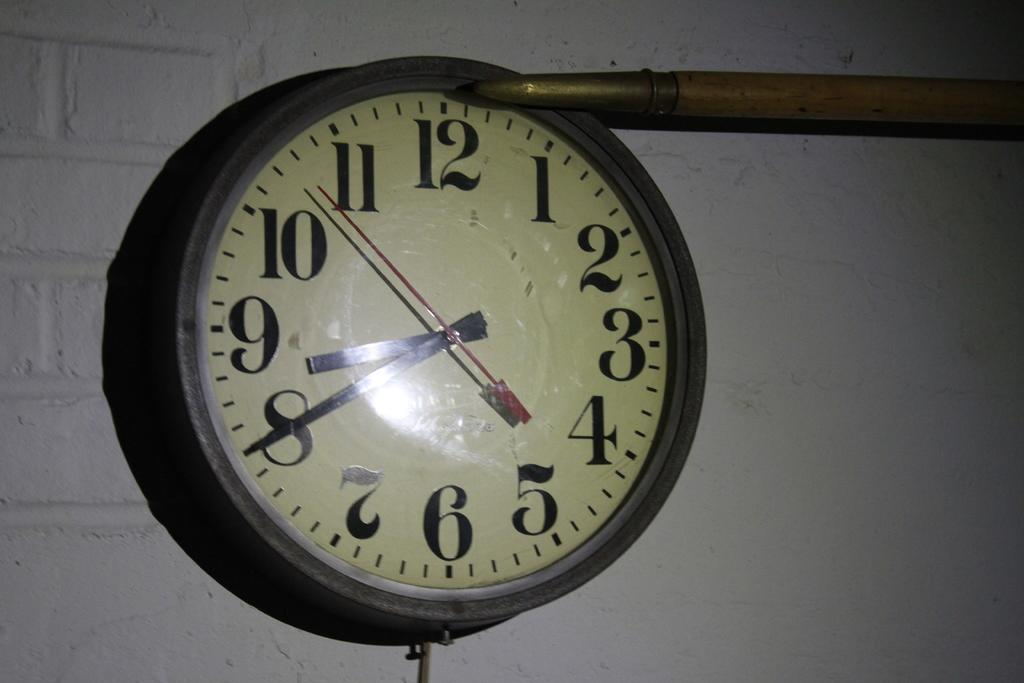<image>
Summarize the visual content of the image. A round clock face that shows it is twenty til nine. 